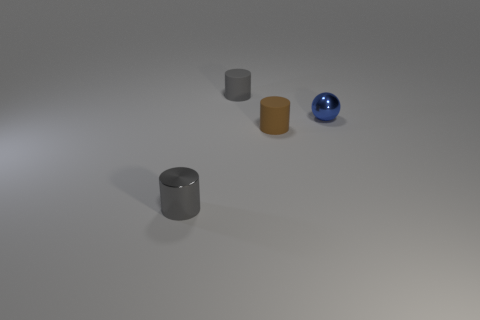Is the small brown object made of the same material as the small blue sphere?
Your response must be concise. No. What number of other small brown cylinders have the same material as the tiny brown cylinder?
Keep it short and to the point. 0. What is the color of the tiny cylinder that is both on the right side of the small gray shiny cylinder and left of the tiny brown cylinder?
Your response must be concise. Gray. Are there any tiny rubber cylinders that are to the left of the gray cylinder behind the tiny gray metal cylinder?
Provide a short and direct response. No. Are there the same number of matte objects right of the ball and small red spheres?
Your answer should be very brief. Yes. There is a gray object that is right of the small thing that is in front of the tiny brown rubber cylinder; what number of cylinders are right of it?
Your answer should be compact. 1. Is there a block of the same size as the gray metallic cylinder?
Keep it short and to the point. No. Are there fewer tiny brown cylinders left of the small brown rubber cylinder than brown rubber cylinders?
Your answer should be very brief. Yes. There is a tiny gray cylinder that is behind the tiny gray object that is in front of the tiny cylinder that is behind the brown matte object; what is it made of?
Offer a very short reply. Rubber. Are there more gray objects left of the small gray matte cylinder than small blue objects that are left of the blue sphere?
Provide a succinct answer. Yes. 